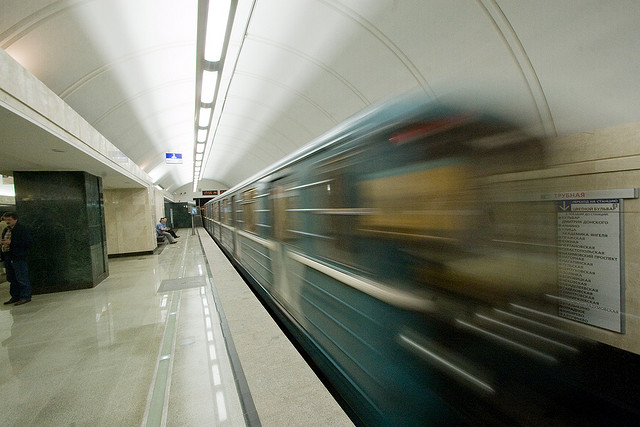What time of day or night might this photo have been taken? Given the lighting conditions and the presence of artificial light, it's plausible that this photo was taken during the evening rush hour or at night. The lighting within the station appears to be active, which is common during times when natural light is low, and the presence of commuters suggests a time of day with regular transit activity. 